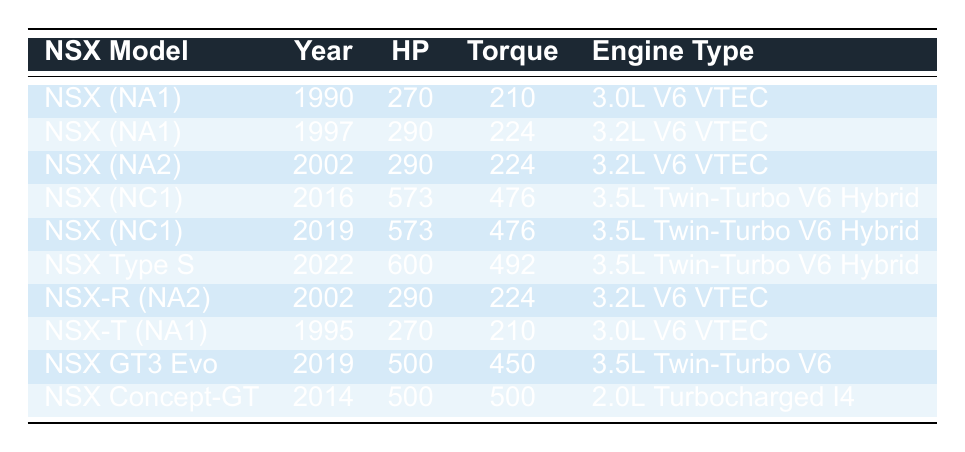What is the horsepower of the NSX Type S? The NSX Type S is listed in the table with a horsepower value of 600 HP in the year 2022.
Answer: 600 HP Which NSX model has the highest torque? The NSX Type S has the highest torque value of 492 lb-ft compared to other models in the table.
Answer: 492 lb-ft How many NSX models have a horsepower of 290 HP? There are three models listed with 290 HP: NSX (NA1) (1997), NSX (NA2) (2002), and NSX-R (NA2) (2002).
Answer: 3 models What is the sum of the horsepower for all NSX models from the NA1 generation? The sum of horsepower for NSX models from the NA1 generation is 270 HP (1990) + 290 HP (1997) + 270 HP (1995) = 830 HP.
Answer: 830 HP Is the NSX GT3 Evo more powerful than the NSX (NC1) models? The NSX GT3 Evo has 500 HP, which is less than the 573 HP of both NSX (NC1) models (2016 and 2019).
Answer: No Which engine type has the highest horsepower rating? The engine type that has the highest horsepower rating is the 3.5L Twin-Turbo V6 Hybrid in the NSX Type S with 600 HP.
Answer: 3.5L Twin-Turbo V6 Hybrid What is the average torque among NSX models from the year 2002? For 2002, there are two models: NSX (NA2) with 224 lb-ft and NSX-R (NA2) with 224 lb-ft. The average torque is (224 + 224) / 2 = 224 lb-ft.
Answer: 224 lb-ft How does the horsepower of the first NSX compare to the last model? The first NSX (NA1) model from 1990 has 270 HP, while the last model listed, NSX Type S (2022), has 600 HP. So, 600 HP - 270 HP = 330 HP difference.
Answer: 330 HP Which NSX model has the same horsepower and torque values as the NSX-R (NA2)? The NSX (NA2) from 2002 also has 290 HP and 224 lb-ft of torque, matching the values of the NSX-R (NA2).
Answer: NSX (NA2) What is the ratio of horsepower to torque for the NSX (NC1) from 2016? For the NSX (NC1) (2016), the horsepower is 573 and the torque is 476. Thus, the ratio is 573 / 476 ≈ 1.20.
Answer: Approximately 1.20 